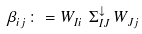Convert formula to latex. <formula><loc_0><loc_0><loc_500><loc_500>\beta ^ { \ } _ { i j } \colon = W ^ { \ } _ { I i } \, \Sigma ^ { \downarrow } _ { I J } \, W ^ { \ } _ { J j }</formula> 